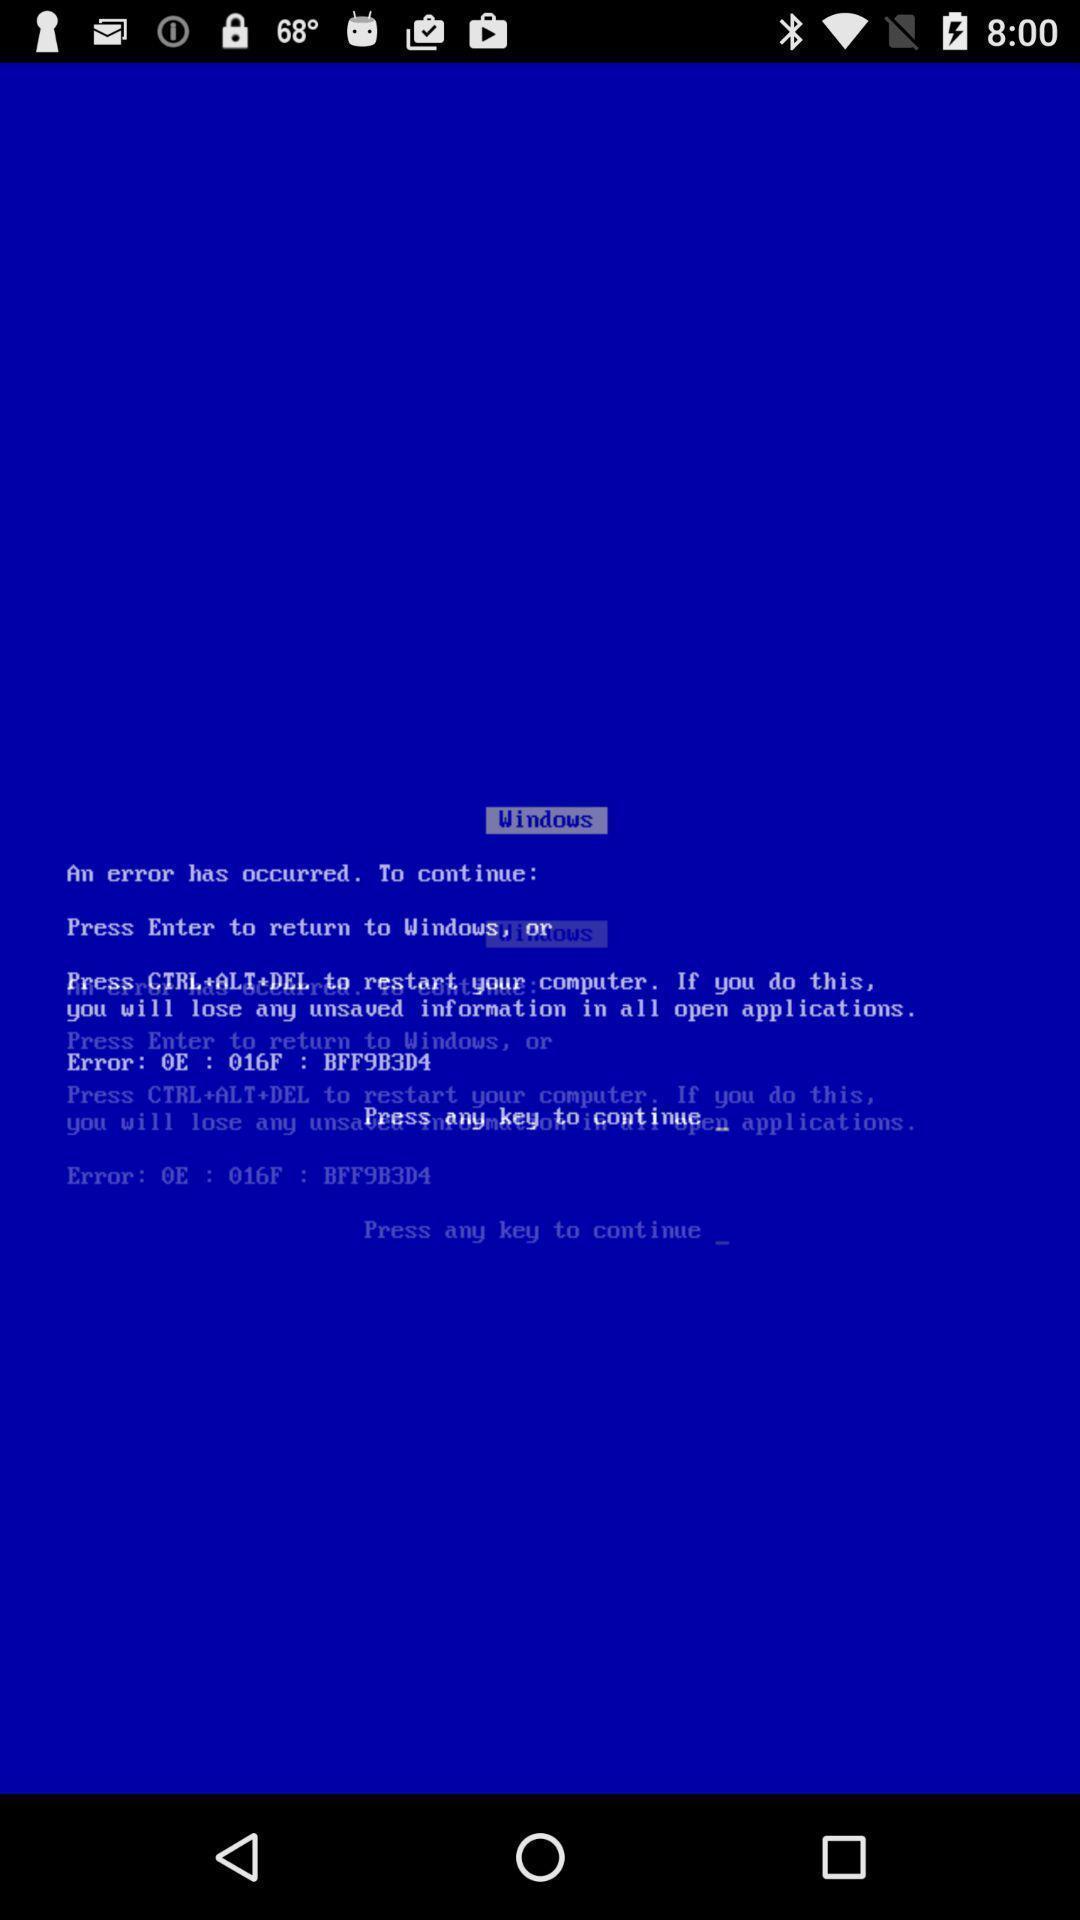What is the overall content of this screenshot? Screen shows about windows. 